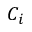<formula> <loc_0><loc_0><loc_500><loc_500>C _ { i }</formula> 